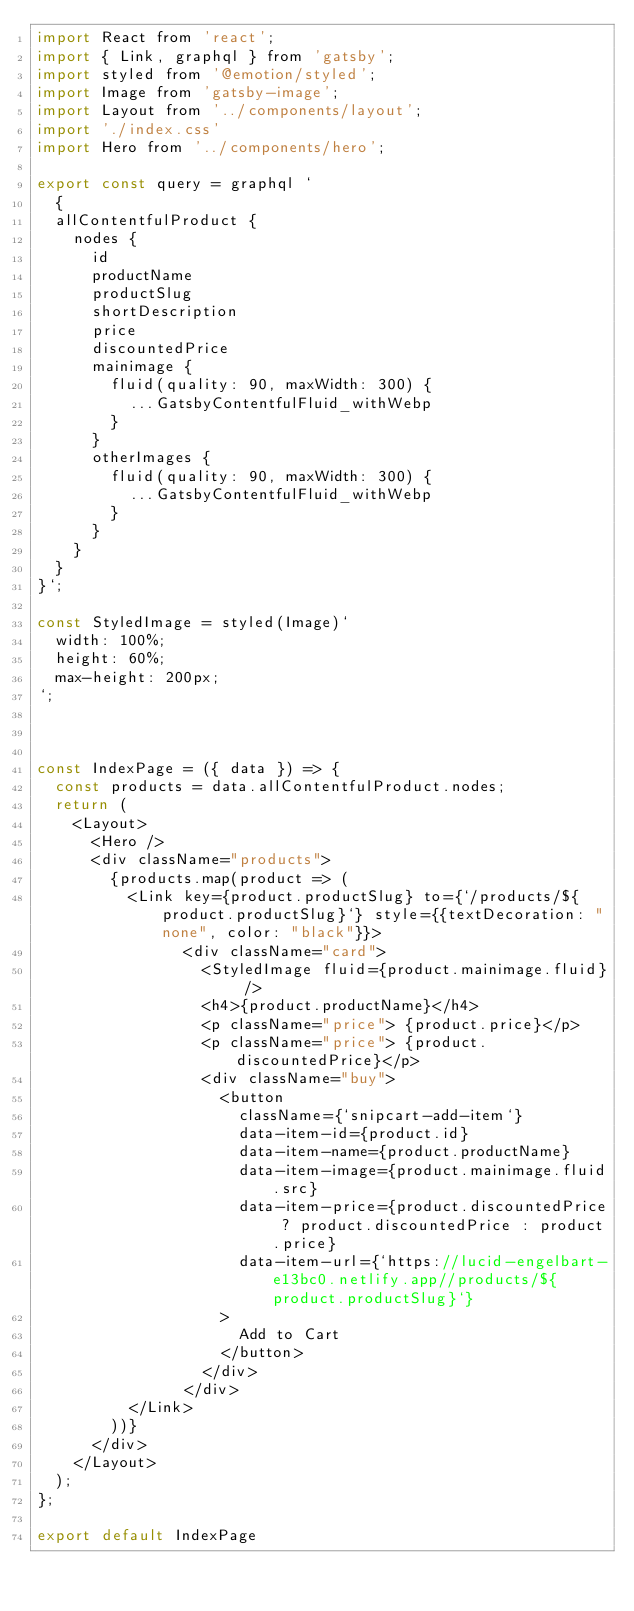<code> <loc_0><loc_0><loc_500><loc_500><_JavaScript_>import React from 'react';
import { Link, graphql } from 'gatsby';
import styled from '@emotion/styled';
import Image from 'gatsby-image';
import Layout from '../components/layout';
import './index.css'
import Hero from '../components/hero';

export const query = graphql `
  {
  allContentfulProduct {
    nodes {
      id
      productName
      productSlug
      shortDescription
      price
      discountedPrice
      mainimage {
        fluid(quality: 90, maxWidth: 300) {
          ...GatsbyContentfulFluid_withWebp
        }
      }
      otherImages {
        fluid(quality: 90, maxWidth: 300) {
          ...GatsbyContentfulFluid_withWebp
        }
      }
    }
  }
}`;

const StyledImage = styled(Image)`
  width: 100%;
  height: 60%;
  max-height: 200px;
`;



const IndexPage = ({ data }) => {
  const products = data.allContentfulProduct.nodes;
  return (
    <Layout>
      <Hero />
      <div className="products">
        {products.map(product => (
          <Link key={product.productSlug} to={`/products/${product.productSlug}`} style={{textDecoration: "none", color: "black"}}>
                <div className="card">
                  <StyledImage fluid={product.mainimage.fluid} />
                  <h4>{product.productName}</h4>
                  <p className="price"> {product.price}</p>
                  <p className="price"> {product.discountedPrice}</p>
                  <div className="buy">
                    <button
                      className={`snipcart-add-item`}
                      data-item-id={product.id}
                      data-item-name={product.productName}
                      data-item-image={product.mainimage.fluid.src}
                      data-item-price={product.discountedPrice ? product.discountedPrice : product.price}
                      data-item-url={`https://lucid-engelbart-e13bc0.netlify.app//products/${product.productSlug}`}
                    >
                      Add to Cart
                    </button>
                  </div>
                </div>
          </Link>
        ))}
      </div>
    </Layout>
  );
};

export default IndexPage
</code> 